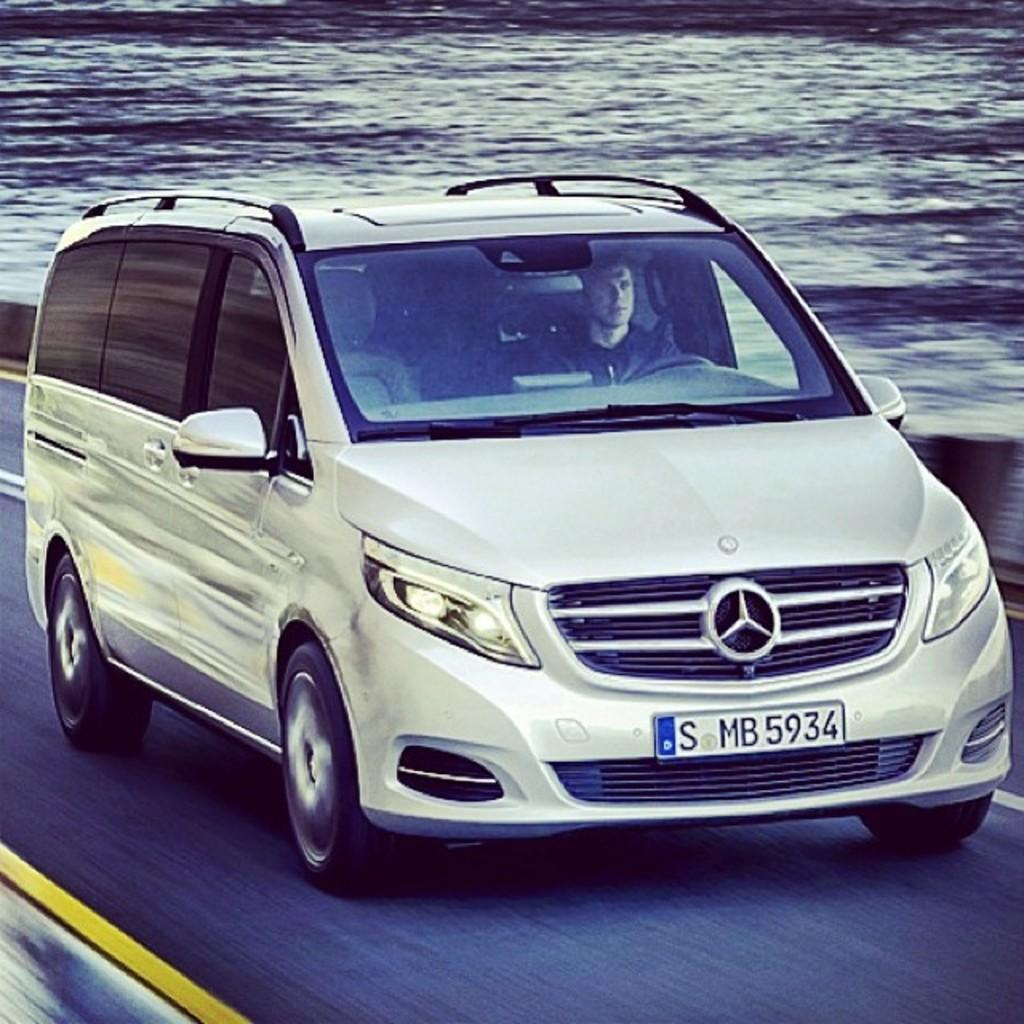<image>
Share a concise interpretation of the image provided. A silver Mercedes minivan with a tag that reads S MB 5934. 